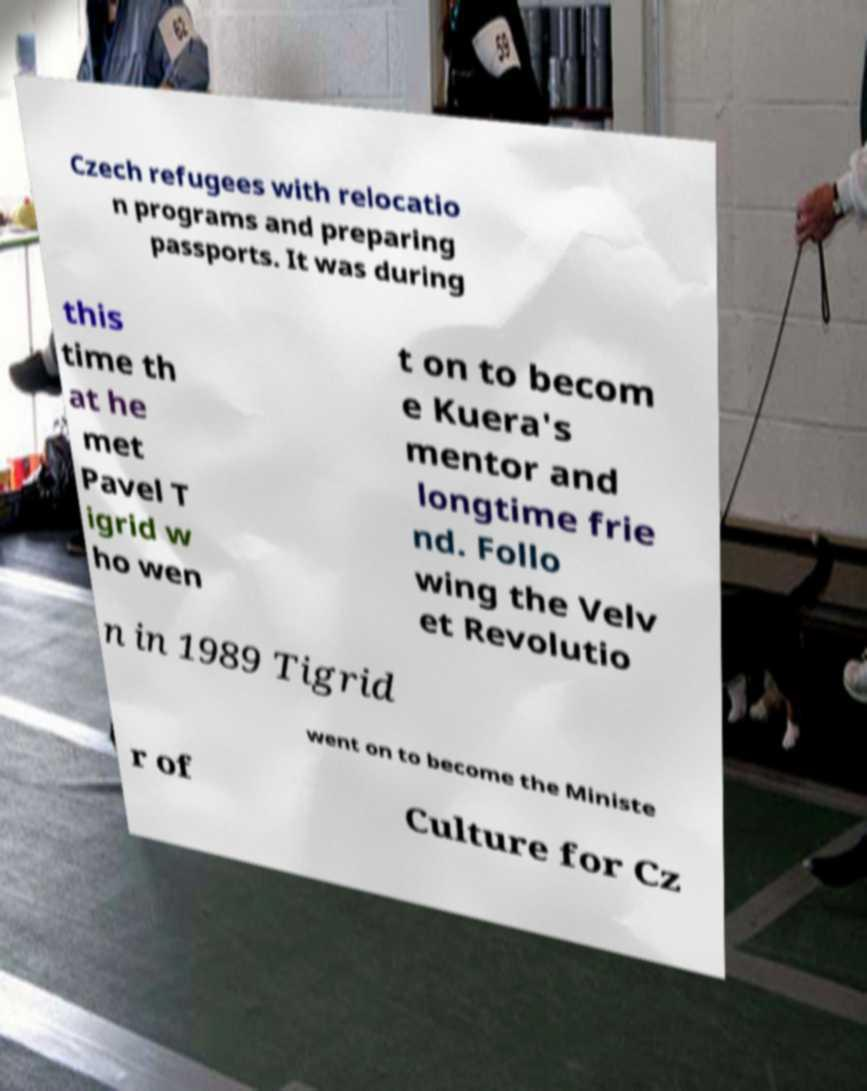Could you assist in decoding the text presented in this image and type it out clearly? Czech refugees with relocatio n programs and preparing passports. It was during this time th at he met Pavel T igrid w ho wen t on to becom e Kuera's mentor and longtime frie nd. Follo wing the Velv et Revolutio n in 1989 Tigrid went on to become the Ministe r of Culture for Cz 